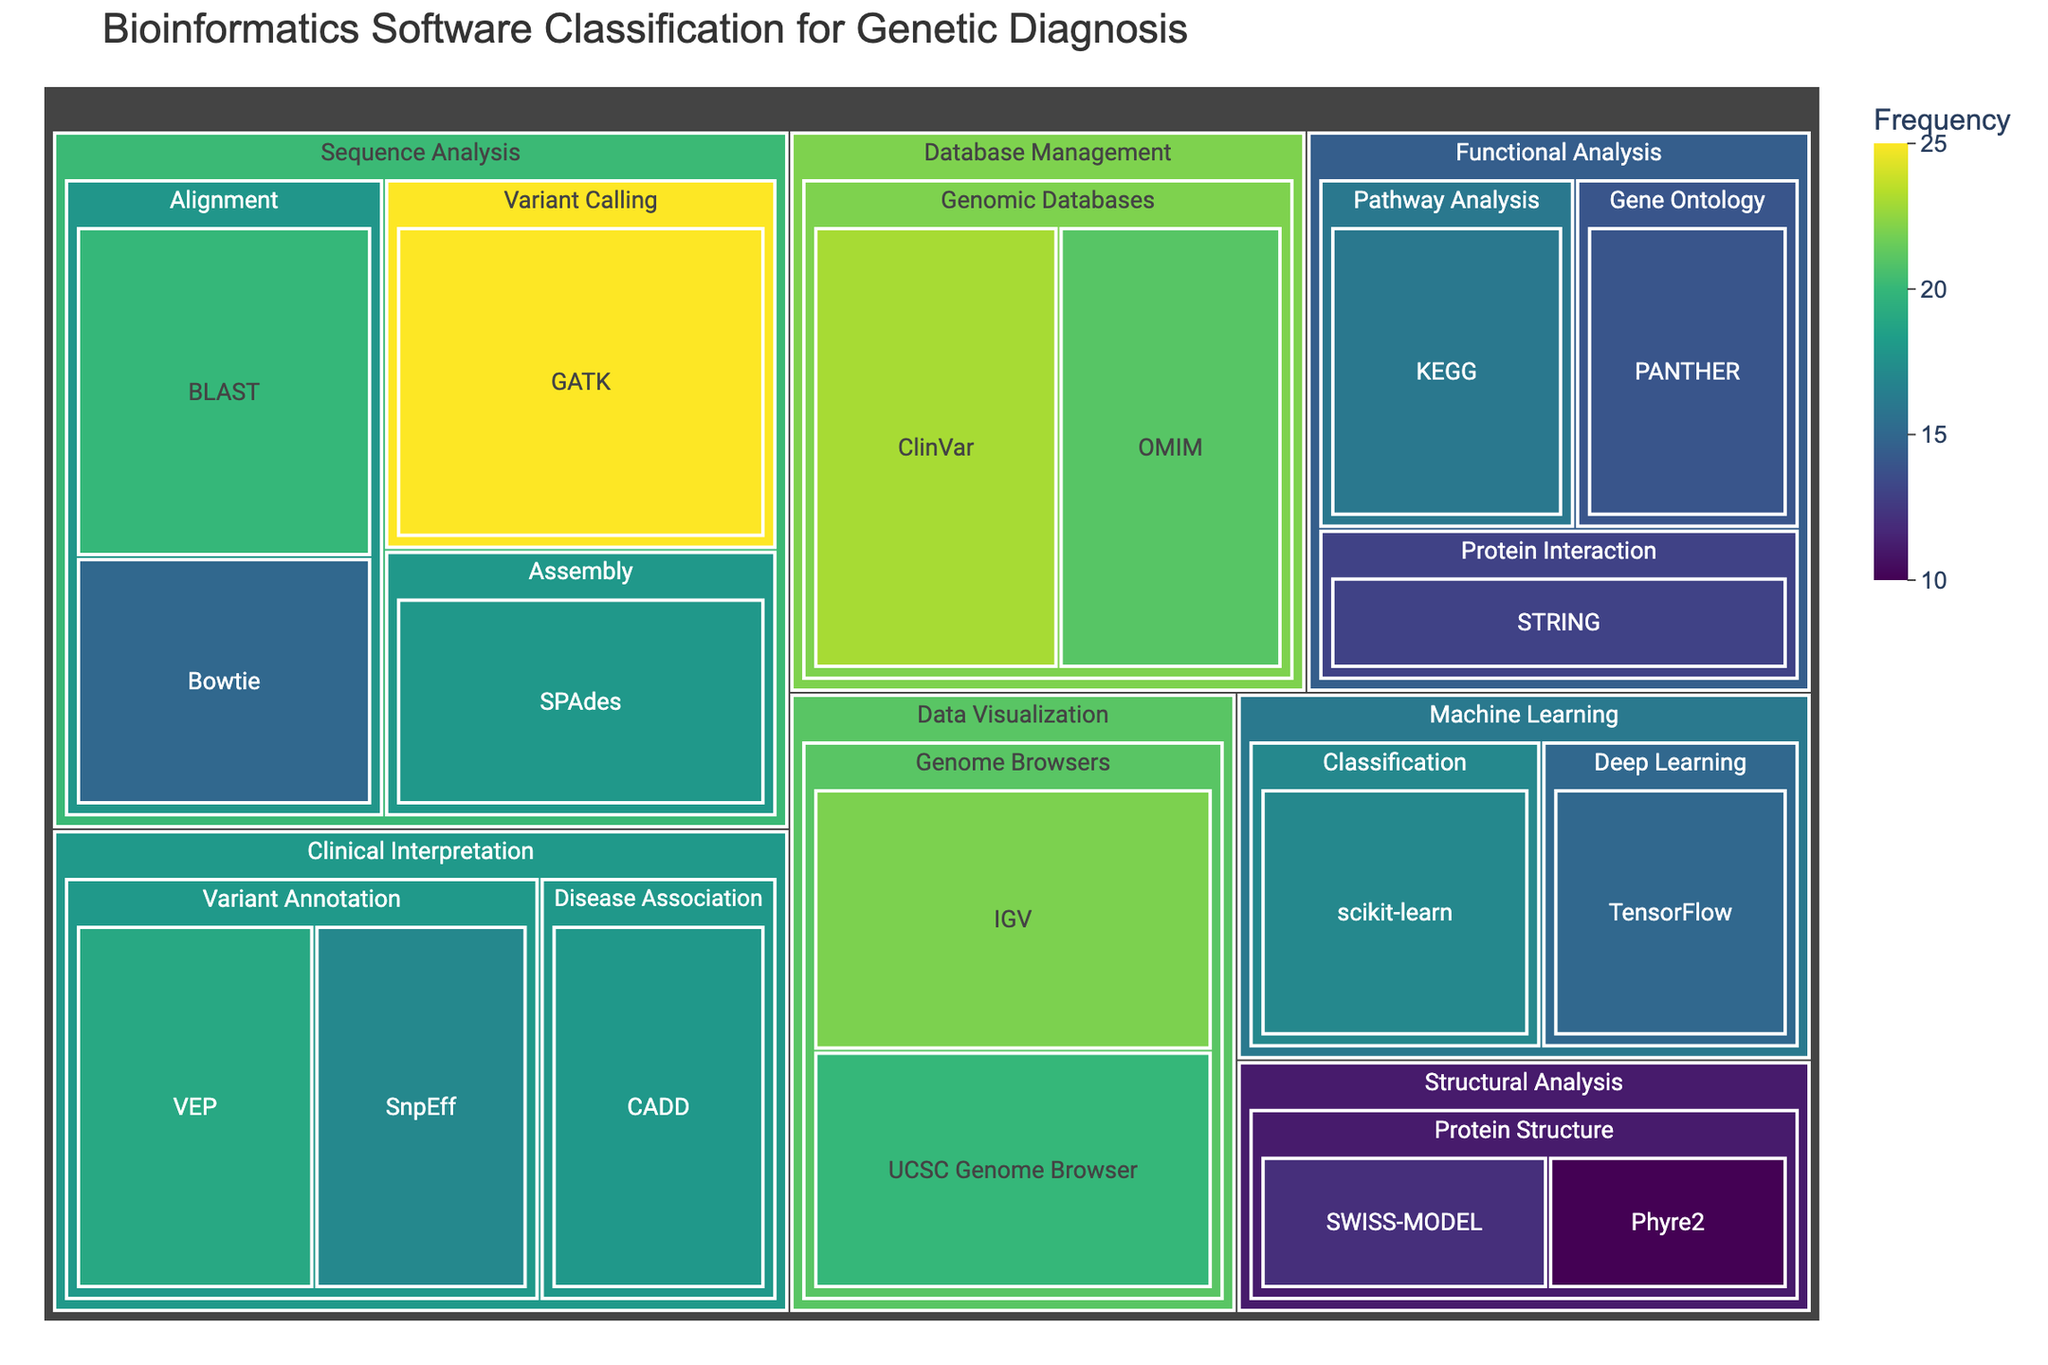What's the title of the figure? The title is typically located at the top of the treemap and provides a summary of what the figure represents.
Answer: Bioinformatics Software Classification for Genetic Diagnosis Which software has the highest frequency? To determine this, look for the largest and darkest colored box in the entire treemap.
Answer: GATK How many subcategories are there under the "Clinical Interpretation" category? Locate the "Clinical Interpretation" category and count the subcategories within it.
Answer: 2 What's the combined frequency of BLAST and Bowtie in the Alignment subcategory? Locate BLAST and Bowtie under the Alignment subcategory, then add their frequencies: 20 + 15.
Answer: 35 Which category has the largest total frequency? To figure this out, aggregate the values of all subcategories within each main category and compare. For example, sum the frequencies in "Sequence Analysis" and compare with others.
Answer: Sequence Analysis Which subcategory in the Data Visualization category has the most tools listed? Identify the Data Visualization category and count the tools within each of its subcategories.
Answer: Genome Browsers Which subcategory has fewer tools: Variant Annotation or Protein Interaction? Count the number of tools in each of the two subcategories and compare.
Answer: Variant Annotation What is the combined frequency of all tools in the Machine Learning category? Sum the frequencies of scikit-learn and TensorFlow within the Machine Learning category: 17 + 15.
Answer: 32 Is there a larger number of tools in the Genomic Databases subcategory or the Protein Structure subcategory? Count the tools in each subcategory and compare the totals.
Answer: Genomic Databases Compare the frequency of the top two tools in the Alignment subcategory. Find the frequencies of the two tools and subtract the smaller figure from the larger one: 20 (BLAST) - 15 (Bowtie).
Answer: 5 